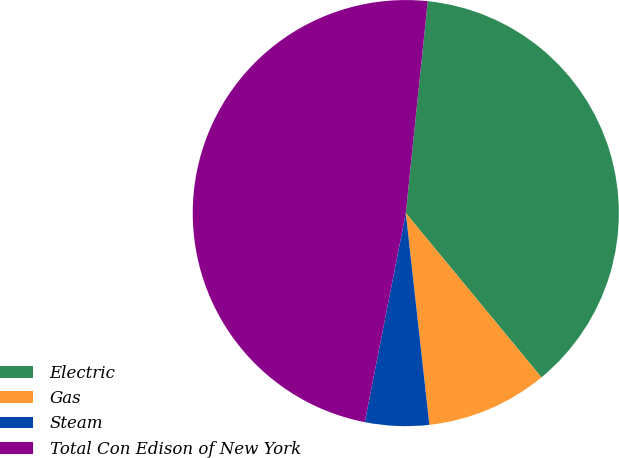Convert chart. <chart><loc_0><loc_0><loc_500><loc_500><pie_chart><fcel>Electric<fcel>Gas<fcel>Steam<fcel>Total Con Edison of New York<nl><fcel>37.37%<fcel>9.22%<fcel>4.85%<fcel>48.56%<nl></chart> 